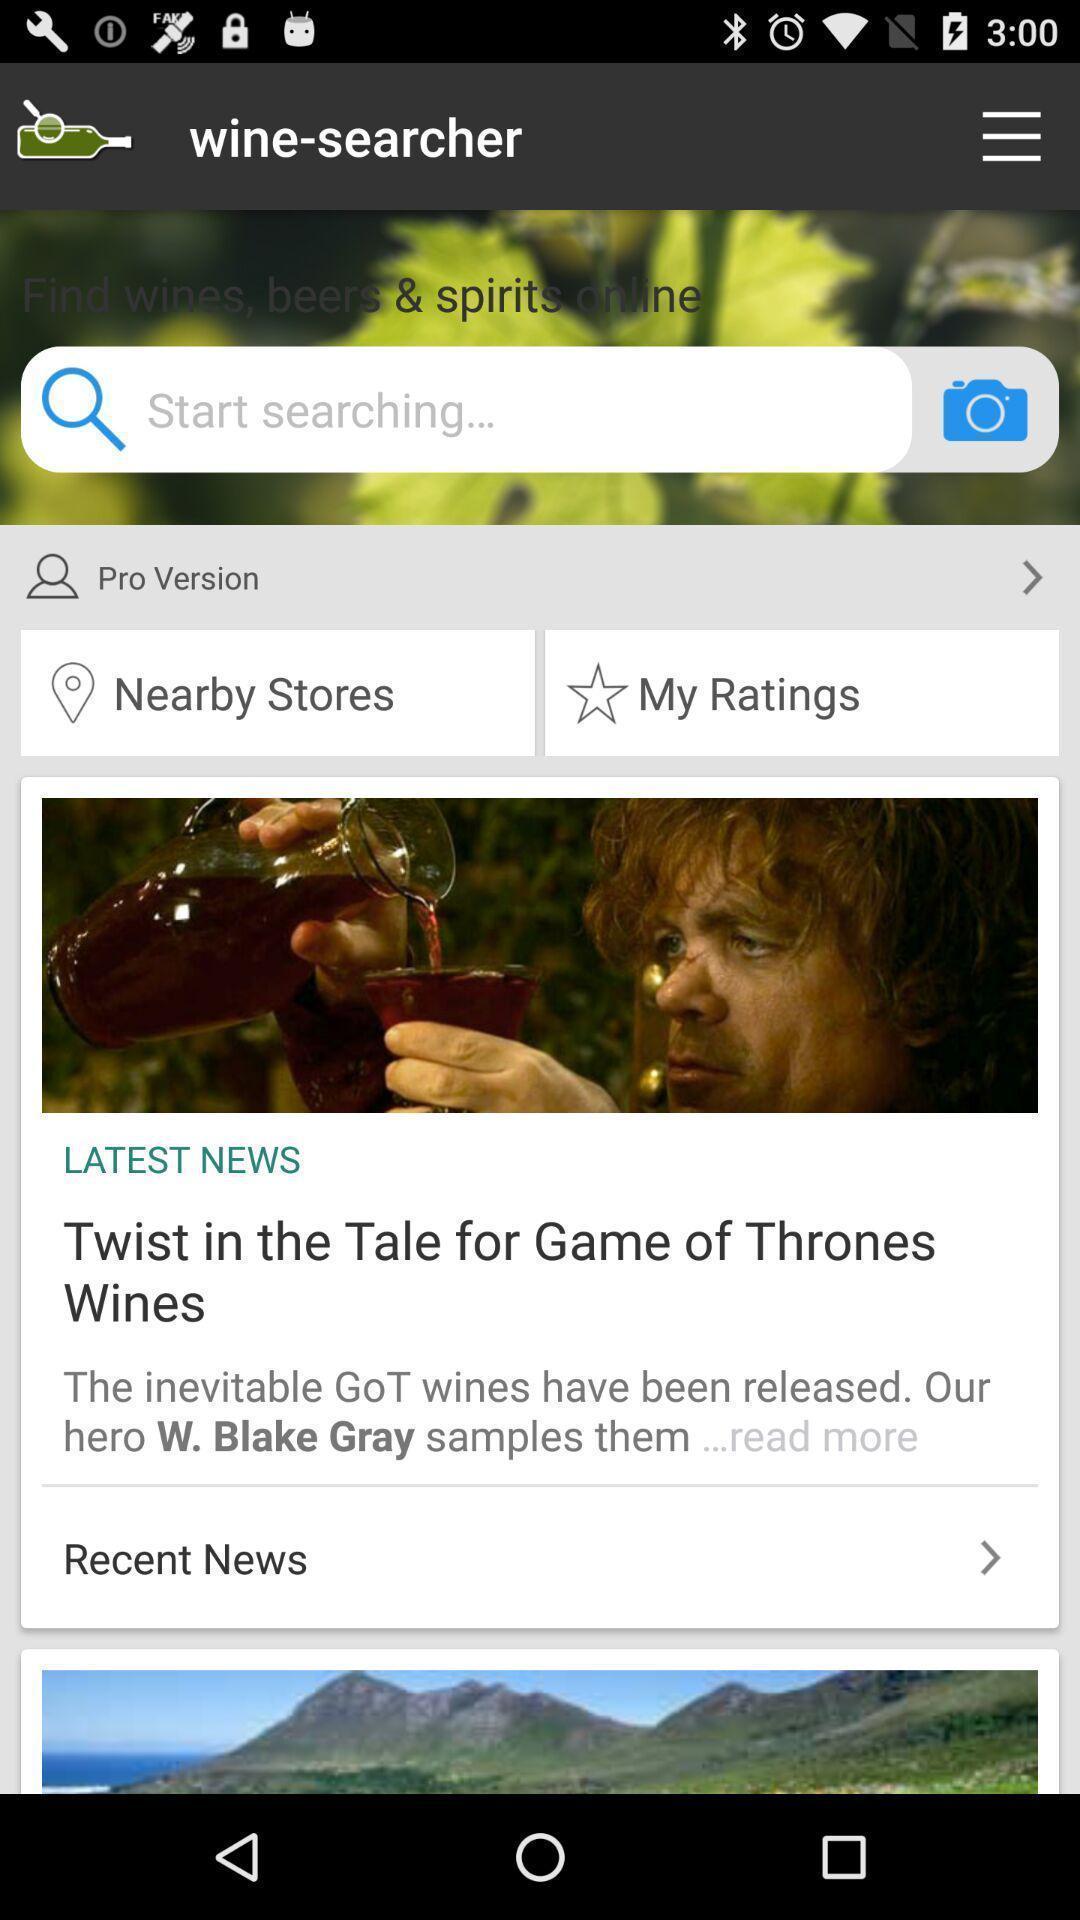Describe the visual elements of this screenshot. Page showing to search near by stores. 